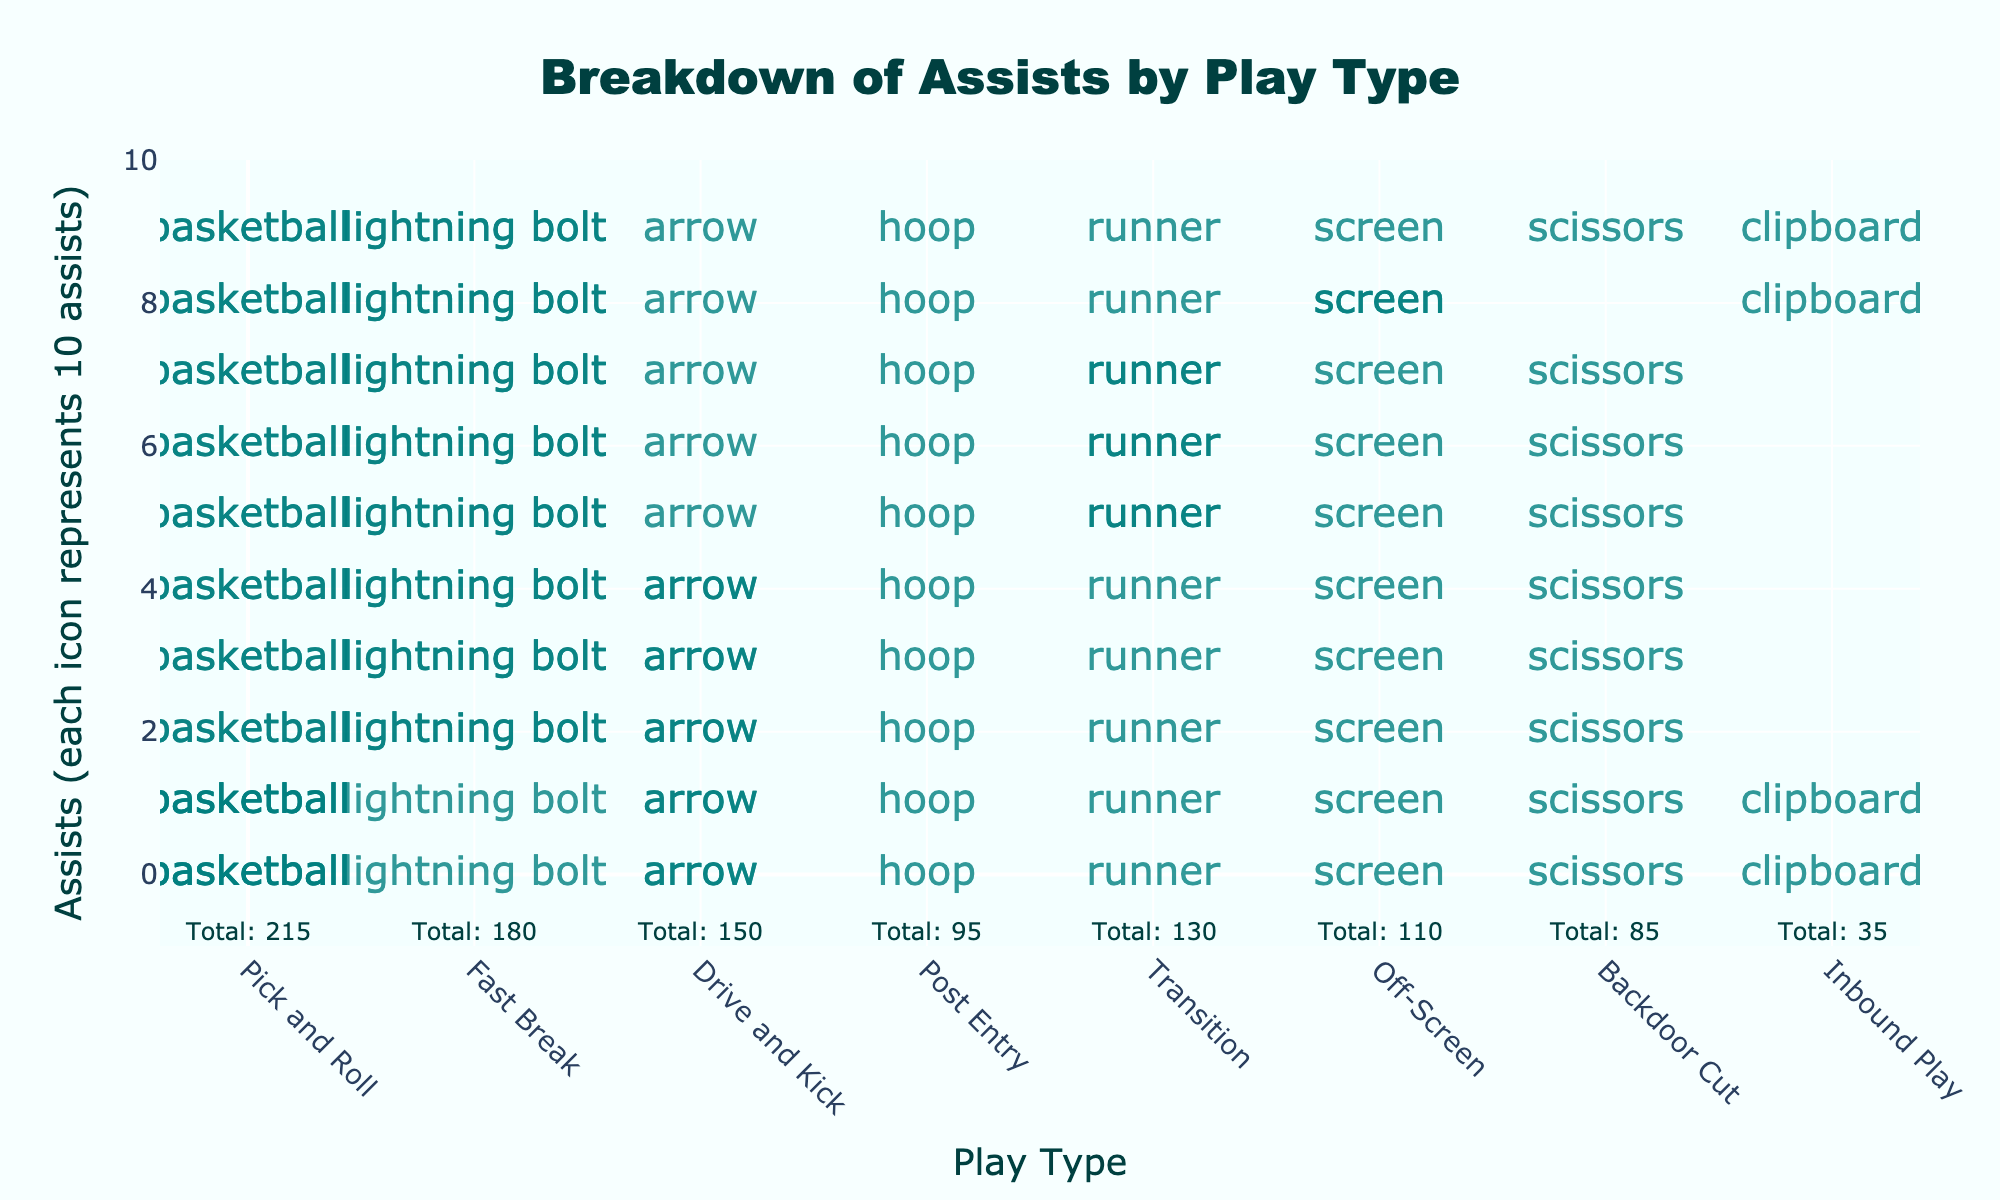What is the title of the figure? Look at the text at the top of the figure which describes what the plot is illustrating.
Answer: Breakdown of Assists by Play Type Which play type has the highest number of assists? Identify the play type that has the highest number of icons representing assists.
Answer: Pick and Roll How many total assists were made by Pick and Roll and Fast Break combined? Add the assists for Pick and Roll (215) and Fast Break (180). 215 + 180 = 395
Answer: 395 Which play types have fewer than 100 assists? Identify play types where the total number of assists is less than 100. These play types are Post Entry, Backdoor Cut, and Inbound Play.
Answer: Post Entry, Backdoor Cut, Inbound Play How many icons represent the Post Entry play type? Each icon stands for 10 assists. Divide the total assists for Post Entry (95) by 10 and round up. 95 / 10 = 9.5, so 10 icons are used.
Answer: 10 icons Which play type has just over 100 assists but fewer than 150 assists? Find play types where the number of assists falls between 100 and 150. Transition has 130 assists, making it the play type in this range.
Answer: Transition What is the difference in the number of assists between Pick and Roll and Drive and Kick? Subtract the number of assists for Drive and Kick (150) from Pick and Roll (215). 215 - 150 = 65
Answer: 65 assists How many total assists were made in Fast Break, Drive and Kick, and Off-Screen? Add the assists for Fast Break (180), Drive and Kick (150), and Off-Screen (110). 180 + 150 + 110 = 440
Answer: 440 What is the least common play type for assists? Identify the play type with the fewest icons representing assists.
Answer: Inbound Play 